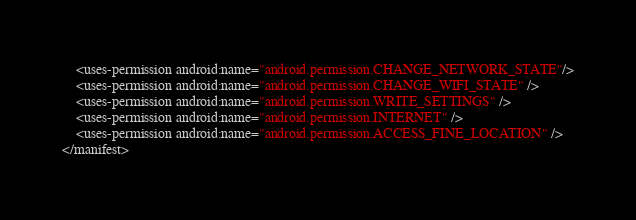<code> <loc_0><loc_0><loc_500><loc_500><_XML_>    <uses-permission android:name="android.permission.CHANGE_NETWORK_STATE"/>
    <uses-permission android:name="android.permission.CHANGE_WIFI_STATE" />
    <uses-permission android:name="android.permission.WRITE_SETTINGS" />
    <uses-permission android:name="android.permission.INTERNET" />
    <uses-permission android:name="android.permission.ACCESS_FINE_LOCATION" />
</manifest>
</code> 